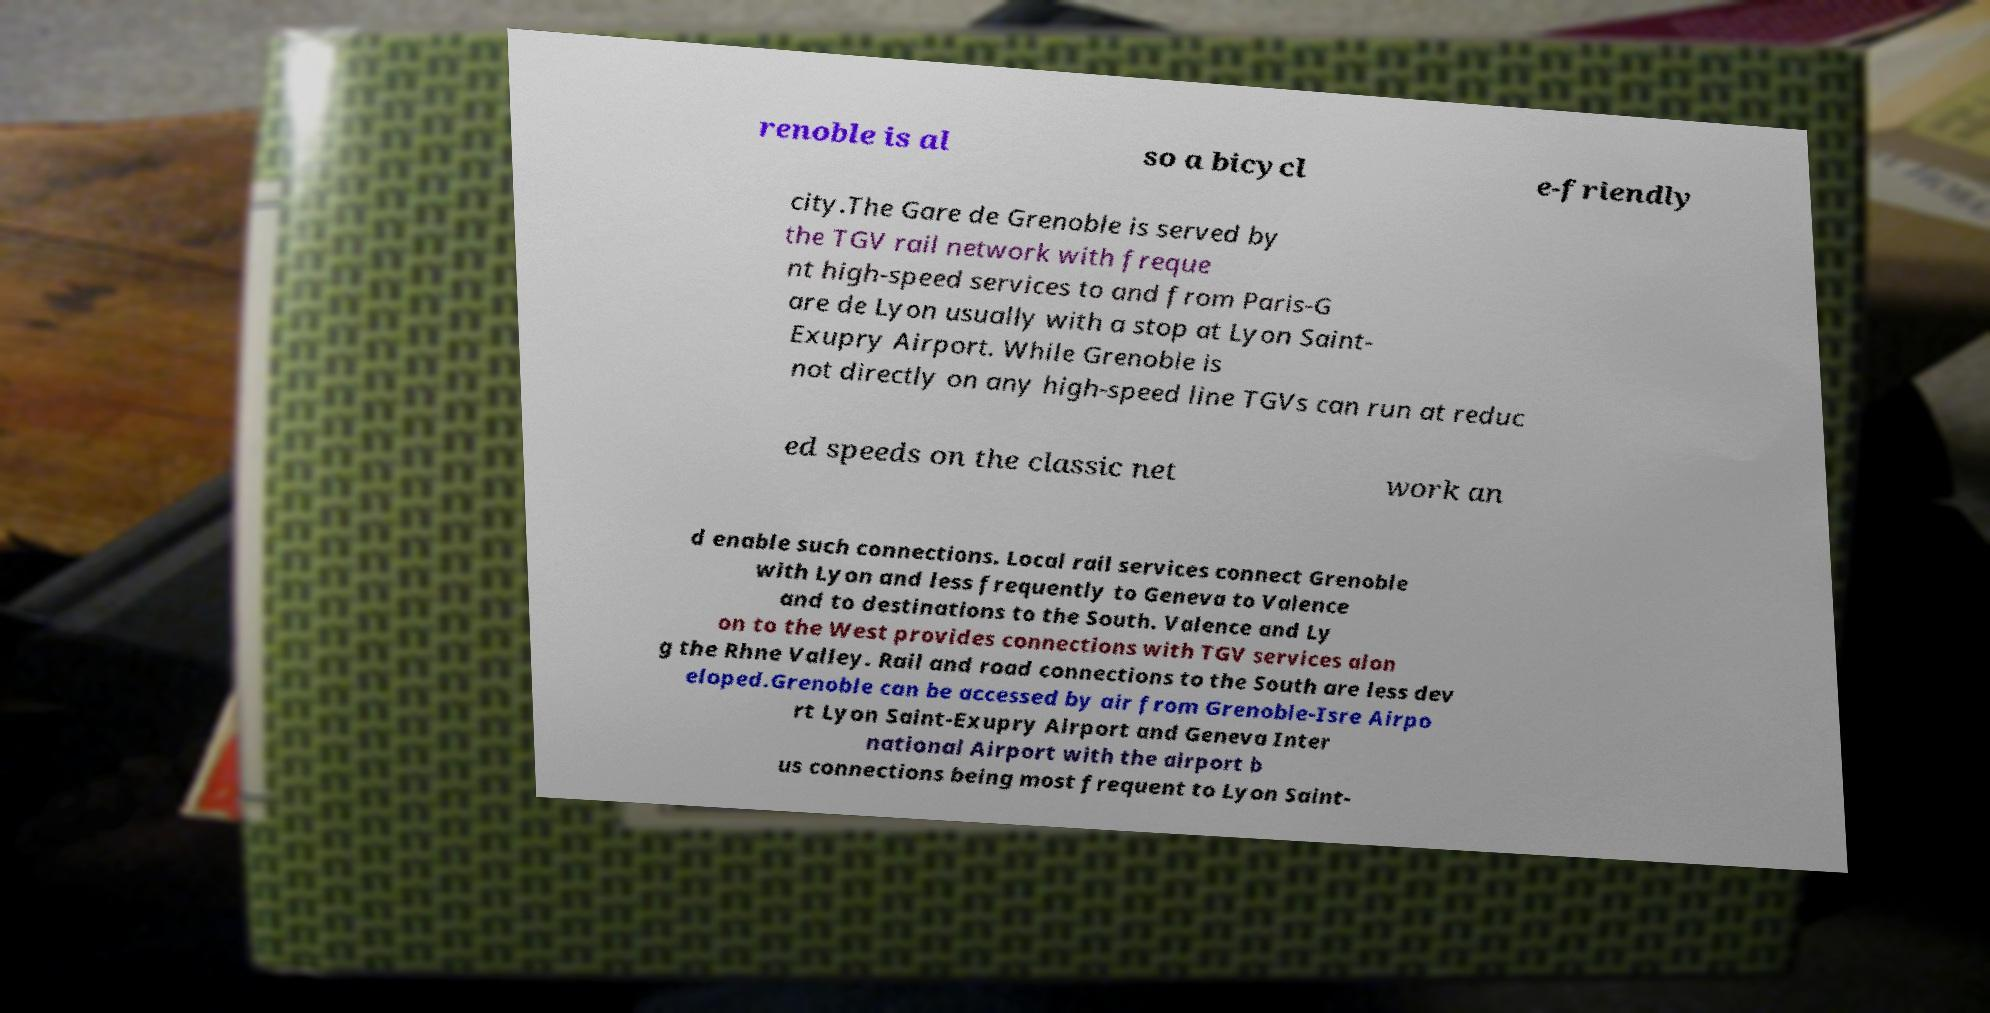Can you accurately transcribe the text from the provided image for me? renoble is al so a bicycl e-friendly city.The Gare de Grenoble is served by the TGV rail network with freque nt high-speed services to and from Paris-G are de Lyon usually with a stop at Lyon Saint- Exupry Airport. While Grenoble is not directly on any high-speed line TGVs can run at reduc ed speeds on the classic net work an d enable such connections. Local rail services connect Grenoble with Lyon and less frequently to Geneva to Valence and to destinations to the South. Valence and Ly on to the West provides connections with TGV services alon g the Rhne Valley. Rail and road connections to the South are less dev eloped.Grenoble can be accessed by air from Grenoble-Isre Airpo rt Lyon Saint-Exupry Airport and Geneva Inter national Airport with the airport b us connections being most frequent to Lyon Saint- 